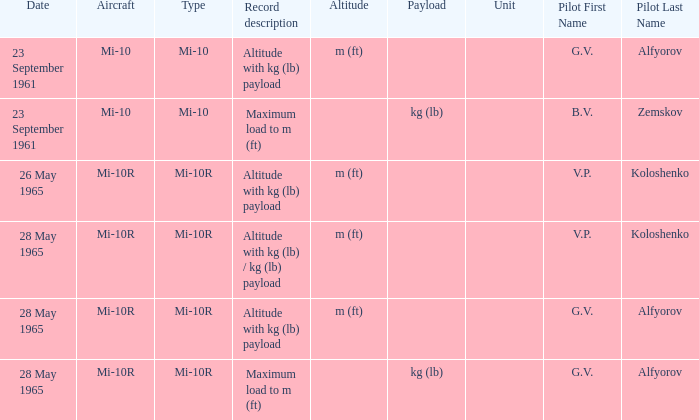Achievement of m (ft), and a Type of mi-10r, and a Pilot of v.p. koloshenko, and a Date of 28 may 1965 had what record description? Altitude with kg (lb) / kg (lb) payload. 